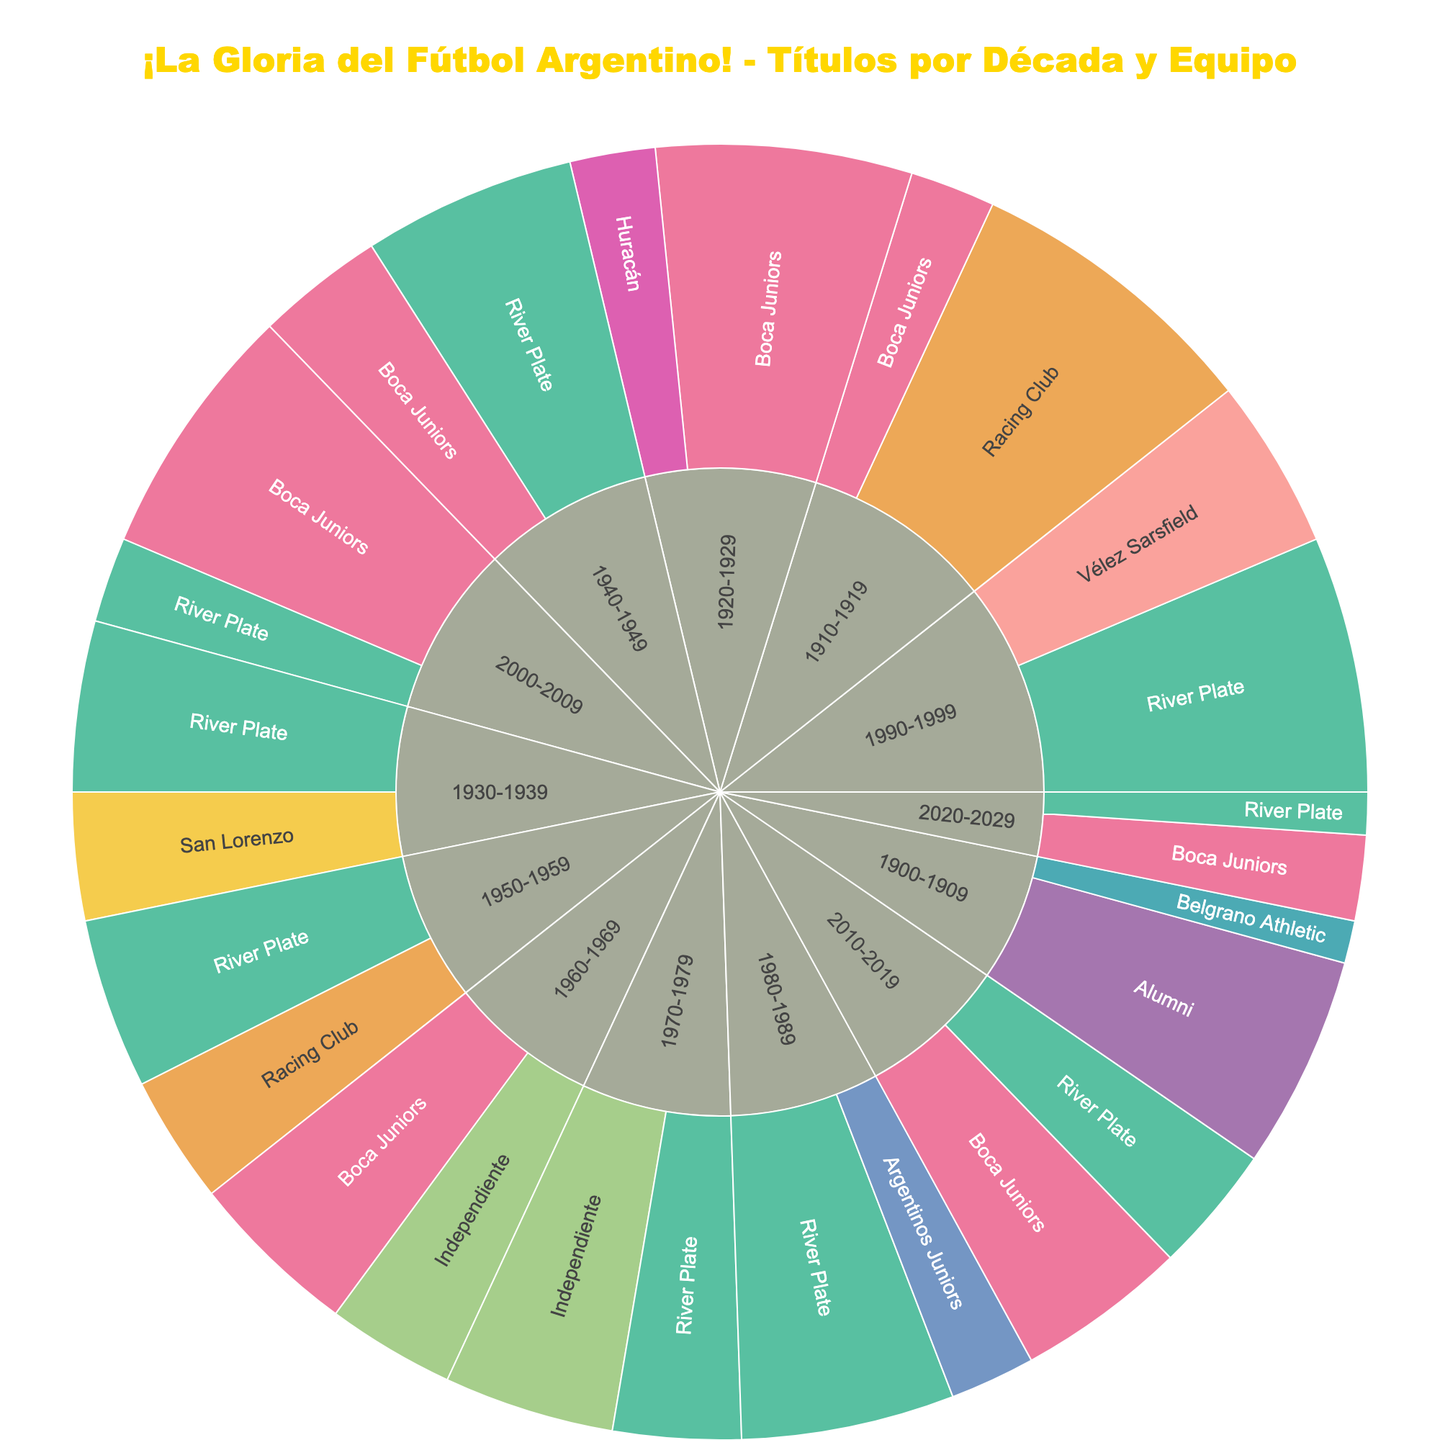What's the decade with the most titles for Boca Juniors? Looking at the sunburst plot, identify the largest sector for Boca Juniors. This sector is the one in the decade 2000-2009, where Boca Juniors has 6 titles.
Answer: 2000-2009 Which team won the most titles in 1980-1989? Identify the decade 1980-1989 and compare the sizes of the sectors within that decade. The largest sector belongs to River Plate, indicating that they won the most titles in this decade.
Answer: River Plate How many total titles did Racing Club win across all decades? Look for sectors labeled "Racing Club" and sum the titles in each of those sectors. The titles are 7 (1910-1919), and 3 (1950-1959), totaling 10 titles.
Answer: 10 Which decade had the highest number of unique title-winning teams? Evaluate each decade and count the unique teams within each decade's sectors. The decade 1930-1939 has River Plate, San Lorenzo, Independiente, and Boca Juniors, totaling 4 unique teams.
Answer: 1930-1939 Are there any teams that won titles in consecutive decades? If so, who? Look at each team's sectors across the plot. River Plate, Boca Juniors, and Racing Club have represented sectors in consecutive decades multiple times.
Answer: River Plate, Boca Juniors, Racing Club What colors are used to represent Boca Juniors and River Plate? Identify the color used in the sectors labeled "Boca Juniors" and "River Plate." Boca Juniors is typically allocated a dark blue color, while River Plate is often shown in red.
Answer: Dark Blue, Red Who had more titles in the 1940s, Boca Juniors or River Plate? Examine the sectors within the 1940-1949 decade for both teams. Boca Juniors won 3 titles, while River Plate won 5 in this period.
Answer: River Plate Which team had the most diverse championship spread throughout the decades? Observe the plot for the team with the most distributed, non-clustered sectors across different decades. River Plate appears in almost every decade with multiple titles.
Answer: River Plate How many titles did Independiente win in total during the 1960s and 1970s? Add up the titles from Independiente in the 1960-1969 (3 titles) and 1970-1979 (4 titles) sectors. The total is 7 titles.
Answer: 7 What's the smallest number of titles won by any team in any given decade? Identify the smallest sectors across all decades, finding that Belgrano Athletic in 1900-1909 won just 1 title.
Answer: 1 